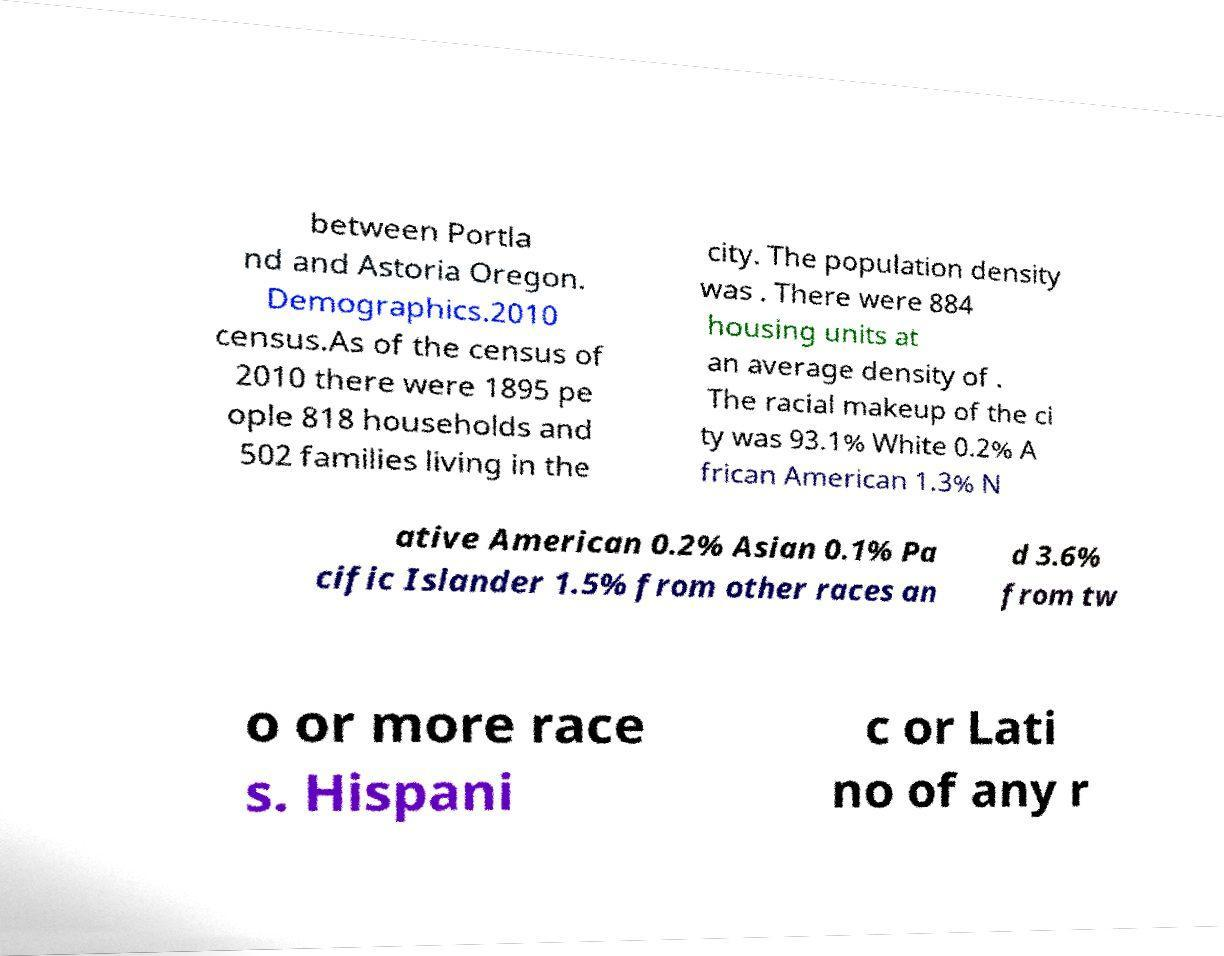Please read and relay the text visible in this image. What does it say? between Portla nd and Astoria Oregon. Demographics.2010 census.As of the census of 2010 there were 1895 pe ople 818 households and 502 families living in the city. The population density was . There were 884 housing units at an average density of . The racial makeup of the ci ty was 93.1% White 0.2% A frican American 1.3% N ative American 0.2% Asian 0.1% Pa cific Islander 1.5% from other races an d 3.6% from tw o or more race s. Hispani c or Lati no of any r 